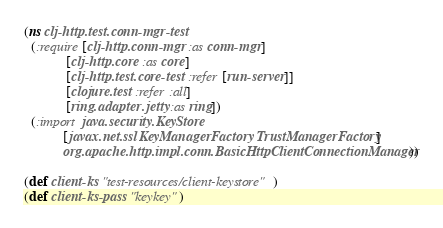<code> <loc_0><loc_0><loc_500><loc_500><_Clojure_>(ns clj-http.test.conn-mgr-test
  (:require [clj-http.conn-mgr :as conn-mgr]
            [clj-http.core :as core]
            [clj-http.test.core-test :refer [run-server]]
            [clojure.test :refer :all]
            [ring.adapter.jetty :as ring])
  (:import java.security.KeyStore
           [javax.net.ssl KeyManagerFactory TrustManagerFactory]
           org.apache.http.impl.conn.BasicHttpClientConnectionManager))

(def client-ks "test-resources/client-keystore")
(def client-ks-pass "keykey")</code> 